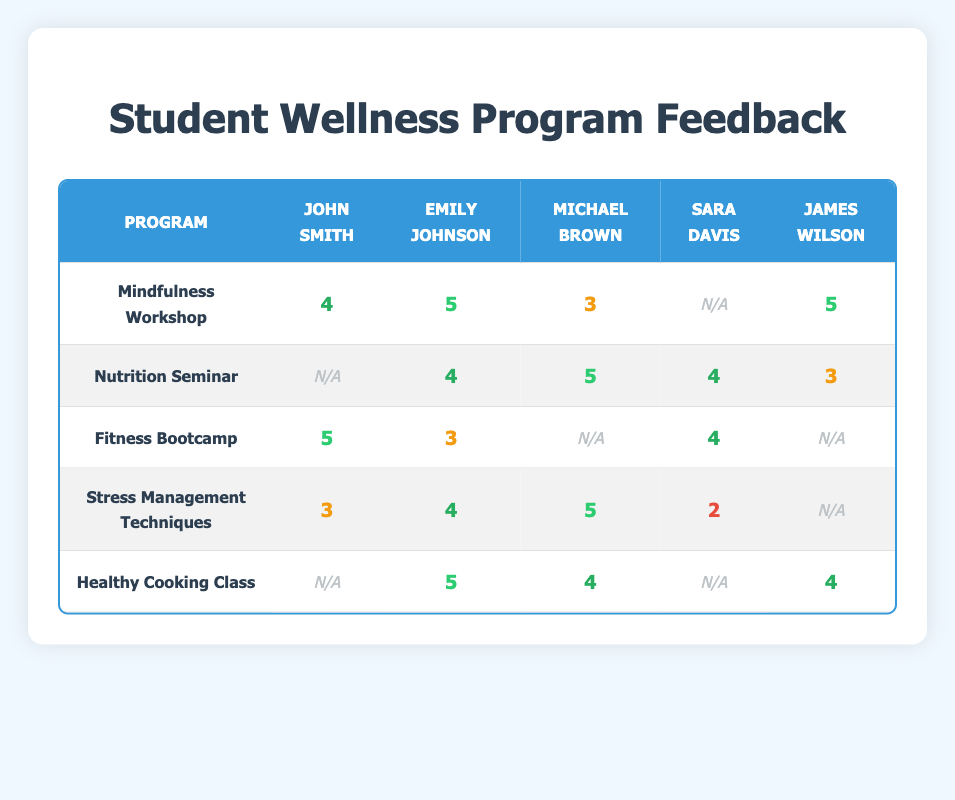What is the feedback score from Emily Johnson for the Mindfulness Workshop? The table indicates that Emily Johnson gave a score of 5 for the Mindfulness Workshop.
Answer: 5 What feedback score did James Wilson give for the Nutrition Seminar? According to the table, James Wilson gave a score of 3 for the Nutrition Seminar.
Answer: 3 Which program received the highest feedback score from John Smith? The highest feedback score from John Smith is 5, which he gave to the Fitness Bootcamp.
Answer: Fitness Bootcamp Is there any program where Michael Brown didn't provide a feedback score? Yes, according to the table, Michael Brown did not provide a score for the Fitness Bootcamp.
Answer: Yes What is the average feedback score for Sara Davis across all programs? Sara Davis’s scores are 2 (Stress Management Techniques) and 4 (Fitness Bootcamp). The average score is (2 + 4) / 2 = 3.
Answer: 3 How many programs did Emily Johnson give a score of 5? Emily Johnson scored 5 in two programs: Mindfulness Workshop and Healthy Cooking Class.
Answer: 2 Which program had the lowest feedback score from any student? The Stress Management Techniques program received the lowest score of 2 from Sara Davis.
Answer: Stress Management Techniques What is the total number of feedback scores provided for the Nutrition Seminar? The Nutrition Seminar received feedback scores from four students: Emily Johnson, Michael Brown, Sara Davis, and James Wilson. Therefore, the total number of scores is 4.
Answer: 4 Which student gave the most feedback scores and how many did they give? John Smith and Sara Davis both provided feedback for four programs each. Therefore, the maximum is 4 scores.
Answer: John Smith and Sara Davis, 4 What is the difference in feedback scores given to the Healthy Cooking Class by Emily Johnson and James Wilson? Emily Johnson scored 5 while James Wilson scored 4 for the Healthy Cooking Class. The difference is 5 - 4 = 1.
Answer: 1 